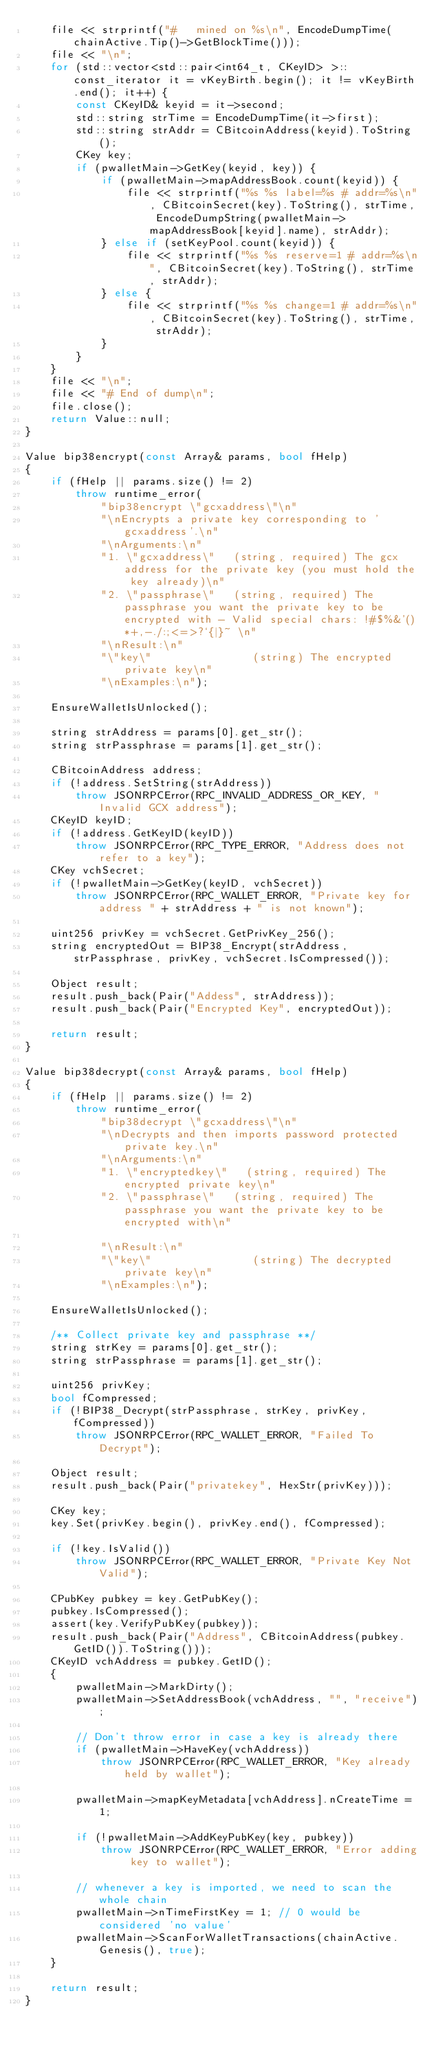<code> <loc_0><loc_0><loc_500><loc_500><_C++_>    file << strprintf("#   mined on %s\n", EncodeDumpTime(chainActive.Tip()->GetBlockTime()));
    file << "\n";
    for (std::vector<std::pair<int64_t, CKeyID> >::const_iterator it = vKeyBirth.begin(); it != vKeyBirth.end(); it++) {
        const CKeyID& keyid = it->second;
        std::string strTime = EncodeDumpTime(it->first);
        std::string strAddr = CBitcoinAddress(keyid).ToString();
        CKey key;
        if (pwalletMain->GetKey(keyid, key)) {
            if (pwalletMain->mapAddressBook.count(keyid)) {
                file << strprintf("%s %s label=%s # addr=%s\n", CBitcoinSecret(key).ToString(), strTime, EncodeDumpString(pwalletMain->mapAddressBook[keyid].name), strAddr);
            } else if (setKeyPool.count(keyid)) {
                file << strprintf("%s %s reserve=1 # addr=%s\n", CBitcoinSecret(key).ToString(), strTime, strAddr);
            } else {
                file << strprintf("%s %s change=1 # addr=%s\n", CBitcoinSecret(key).ToString(), strTime, strAddr);
            }
        }
    }
    file << "\n";
    file << "# End of dump\n";
    file.close();
    return Value::null;
}

Value bip38encrypt(const Array& params, bool fHelp)
{
    if (fHelp || params.size() != 2)
        throw runtime_error(
            "bip38encrypt \"gcxaddress\"\n"
            "\nEncrypts a private key corresponding to 'gcxaddress'.\n"
            "\nArguments:\n"
            "1. \"gcxaddress\"   (string, required) The gcx address for the private key (you must hold the key already)\n"
            "2. \"passphrase\"   (string, required) The passphrase you want the private key to be encrypted with - Valid special chars: !#$%&'()*+,-./:;<=>?`{|}~ \n"
            "\nResult:\n"
            "\"key\"                (string) The encrypted private key\n"
            "\nExamples:\n");

    EnsureWalletIsUnlocked();

    string strAddress = params[0].get_str();
    string strPassphrase = params[1].get_str();

    CBitcoinAddress address;
    if (!address.SetString(strAddress))
        throw JSONRPCError(RPC_INVALID_ADDRESS_OR_KEY, "Invalid GCX address");
    CKeyID keyID;
    if (!address.GetKeyID(keyID))
        throw JSONRPCError(RPC_TYPE_ERROR, "Address does not refer to a key");
    CKey vchSecret;
    if (!pwalletMain->GetKey(keyID, vchSecret))
        throw JSONRPCError(RPC_WALLET_ERROR, "Private key for address " + strAddress + " is not known");

    uint256 privKey = vchSecret.GetPrivKey_256();
    string encryptedOut = BIP38_Encrypt(strAddress, strPassphrase, privKey, vchSecret.IsCompressed());

    Object result;
    result.push_back(Pair("Addess", strAddress));
    result.push_back(Pair("Encrypted Key", encryptedOut));

    return result;
}

Value bip38decrypt(const Array& params, bool fHelp)
{
    if (fHelp || params.size() != 2)
        throw runtime_error(
            "bip38decrypt \"gcxaddress\"\n"
            "\nDecrypts and then imports password protected private key.\n"
            "\nArguments:\n"
            "1. \"encryptedkey\"   (string, required) The encrypted private key\n"
            "2. \"passphrase\"   (string, required) The passphrase you want the private key to be encrypted with\n"

            "\nResult:\n"
            "\"key\"                (string) The decrypted private key\n"
            "\nExamples:\n");

    EnsureWalletIsUnlocked();

    /** Collect private key and passphrase **/
    string strKey = params[0].get_str();
    string strPassphrase = params[1].get_str();

    uint256 privKey;
    bool fCompressed;
    if (!BIP38_Decrypt(strPassphrase, strKey, privKey, fCompressed))
        throw JSONRPCError(RPC_WALLET_ERROR, "Failed To Decrypt");

    Object result;
    result.push_back(Pair("privatekey", HexStr(privKey)));

    CKey key;
    key.Set(privKey.begin(), privKey.end(), fCompressed);

    if (!key.IsValid())
        throw JSONRPCError(RPC_WALLET_ERROR, "Private Key Not Valid");

    CPubKey pubkey = key.GetPubKey();
    pubkey.IsCompressed();
    assert(key.VerifyPubKey(pubkey));
    result.push_back(Pair("Address", CBitcoinAddress(pubkey.GetID()).ToString()));
    CKeyID vchAddress = pubkey.GetID();
    {
        pwalletMain->MarkDirty();
        pwalletMain->SetAddressBook(vchAddress, "", "receive");

        // Don't throw error in case a key is already there
        if (pwalletMain->HaveKey(vchAddress))
            throw JSONRPCError(RPC_WALLET_ERROR, "Key already held by wallet");

        pwalletMain->mapKeyMetadata[vchAddress].nCreateTime = 1;

        if (!pwalletMain->AddKeyPubKey(key, pubkey))
            throw JSONRPCError(RPC_WALLET_ERROR, "Error adding key to wallet");

        // whenever a key is imported, we need to scan the whole chain
        pwalletMain->nTimeFirstKey = 1; // 0 would be considered 'no value'
        pwalletMain->ScanForWalletTransactions(chainActive.Genesis(), true);
    }

    return result;
}
</code> 